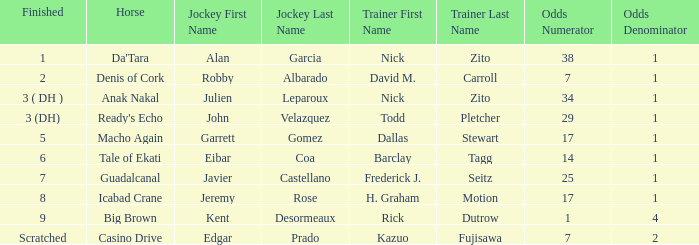What are the likelihoods for instructor barclay tagg? 14-1. 